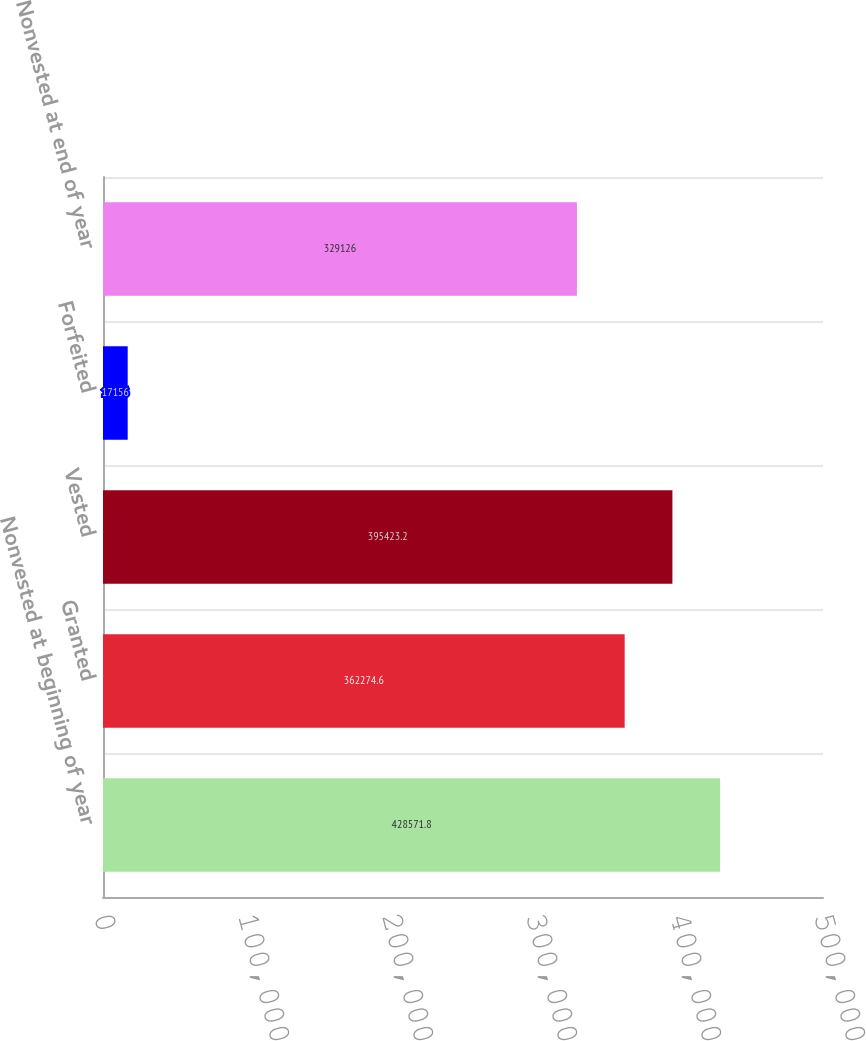<chart> <loc_0><loc_0><loc_500><loc_500><bar_chart><fcel>Nonvested at beginning of year<fcel>Granted<fcel>Vested<fcel>Forfeited<fcel>Nonvested at end of year<nl><fcel>428572<fcel>362275<fcel>395423<fcel>17156<fcel>329126<nl></chart> 